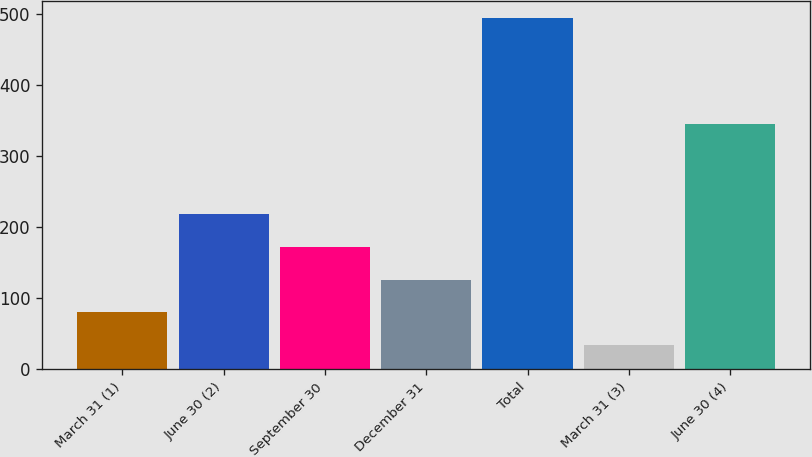Convert chart. <chart><loc_0><loc_0><loc_500><loc_500><bar_chart><fcel>March 31 (1)<fcel>June 30 (2)<fcel>September 30<fcel>December 31<fcel>Total<fcel>March 31 (3)<fcel>June 30 (4)<nl><fcel>80<fcel>218<fcel>172<fcel>126<fcel>494<fcel>34<fcel>345<nl></chart> 